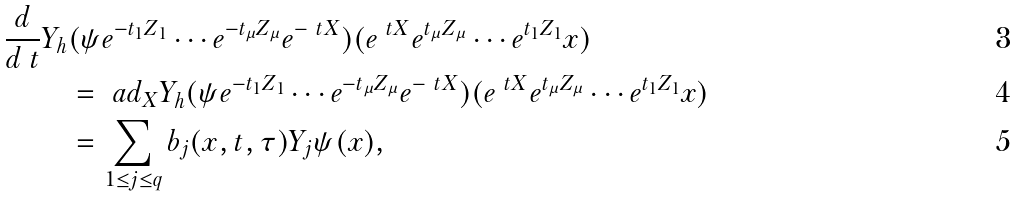Convert formula to latex. <formula><loc_0><loc_0><loc_500><loc_500>\frac { d } { d \ t } Y _ { h } & ( \psi e ^ { - t _ { 1 } Z _ { 1 } } \cdots e ^ { - t _ { \mu } Z _ { \mu } } e ^ { - \ t X } ) ( e ^ { \ t X } e ^ { t _ { \mu } Z _ { \mu } } \cdots e ^ { t _ { 1 } Z _ { 1 } } x ) \\ & = \ a d _ { X } { Y _ { h } } ( \psi e ^ { - t _ { 1 } Z _ { 1 } } \cdots e ^ { - t _ { \mu } Z _ { \mu } } e ^ { - \ t X } ) ( e ^ { \ t X } e ^ { t _ { \mu } Z _ { \mu } } \cdots e ^ { t _ { 1 } Z _ { 1 } } x ) \\ & = \sum _ { 1 \leq j \leq q } b _ { j } ( x , t , \tau ) Y _ { j } \psi ( x ) ,</formula> 